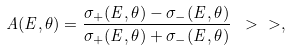Convert formula to latex. <formula><loc_0><loc_0><loc_500><loc_500>A ( E , \theta ) = \frac { \sigma _ { + } ( E , \theta ) - \sigma _ { - } ( E , \theta ) } { \sigma _ { + } ( E , \theta ) + \sigma _ { - } ( E , \theta ) } \ > \ > ,</formula> 